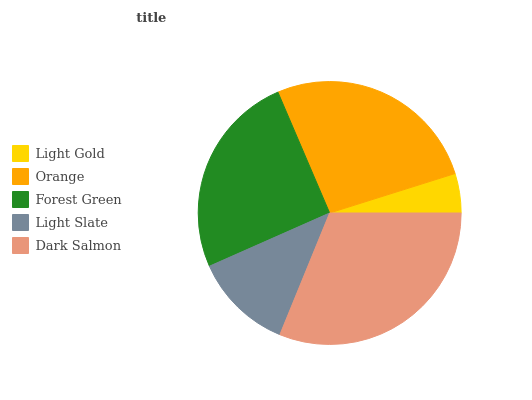Is Light Gold the minimum?
Answer yes or no. Yes. Is Dark Salmon the maximum?
Answer yes or no. Yes. Is Orange the minimum?
Answer yes or no. No. Is Orange the maximum?
Answer yes or no. No. Is Orange greater than Light Gold?
Answer yes or no. Yes. Is Light Gold less than Orange?
Answer yes or no. Yes. Is Light Gold greater than Orange?
Answer yes or no. No. Is Orange less than Light Gold?
Answer yes or no. No. Is Forest Green the high median?
Answer yes or no. Yes. Is Forest Green the low median?
Answer yes or no. Yes. Is Light Gold the high median?
Answer yes or no. No. Is Orange the low median?
Answer yes or no. No. 